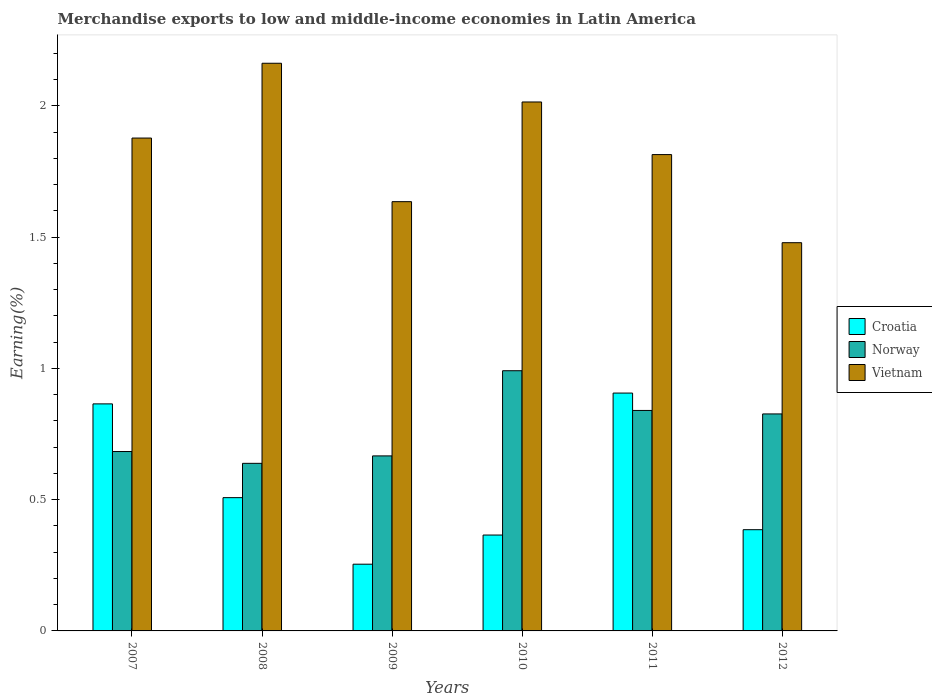How many groups of bars are there?
Your answer should be very brief. 6. Are the number of bars per tick equal to the number of legend labels?
Your answer should be compact. Yes. How many bars are there on the 1st tick from the left?
Your answer should be very brief. 3. How many bars are there on the 2nd tick from the right?
Your response must be concise. 3. What is the label of the 5th group of bars from the left?
Ensure brevity in your answer.  2011. What is the percentage of amount earned from merchandise exports in Croatia in 2010?
Your answer should be very brief. 0.37. Across all years, what is the maximum percentage of amount earned from merchandise exports in Croatia?
Your answer should be very brief. 0.91. Across all years, what is the minimum percentage of amount earned from merchandise exports in Vietnam?
Ensure brevity in your answer.  1.48. In which year was the percentage of amount earned from merchandise exports in Croatia minimum?
Ensure brevity in your answer.  2009. What is the total percentage of amount earned from merchandise exports in Croatia in the graph?
Ensure brevity in your answer.  3.28. What is the difference between the percentage of amount earned from merchandise exports in Croatia in 2008 and that in 2010?
Keep it short and to the point. 0.14. What is the difference between the percentage of amount earned from merchandise exports in Vietnam in 2011 and the percentage of amount earned from merchandise exports in Croatia in 2010?
Offer a terse response. 1.45. What is the average percentage of amount earned from merchandise exports in Croatia per year?
Ensure brevity in your answer.  0.55. In the year 2008, what is the difference between the percentage of amount earned from merchandise exports in Norway and percentage of amount earned from merchandise exports in Croatia?
Give a very brief answer. 0.13. What is the ratio of the percentage of amount earned from merchandise exports in Norway in 2007 to that in 2008?
Ensure brevity in your answer.  1.07. Is the percentage of amount earned from merchandise exports in Vietnam in 2008 less than that in 2010?
Ensure brevity in your answer.  No. What is the difference between the highest and the second highest percentage of amount earned from merchandise exports in Norway?
Your response must be concise. 0.15. What is the difference between the highest and the lowest percentage of amount earned from merchandise exports in Vietnam?
Give a very brief answer. 0.68. In how many years, is the percentage of amount earned from merchandise exports in Norway greater than the average percentage of amount earned from merchandise exports in Norway taken over all years?
Provide a short and direct response. 3. Is the sum of the percentage of amount earned from merchandise exports in Croatia in 2007 and 2010 greater than the maximum percentage of amount earned from merchandise exports in Vietnam across all years?
Keep it short and to the point. No. What does the 1st bar from the left in 2009 represents?
Provide a succinct answer. Croatia. Are all the bars in the graph horizontal?
Your answer should be compact. No. How many years are there in the graph?
Give a very brief answer. 6. What is the difference between two consecutive major ticks on the Y-axis?
Your response must be concise. 0.5. Are the values on the major ticks of Y-axis written in scientific E-notation?
Your answer should be compact. No. Does the graph contain any zero values?
Ensure brevity in your answer.  No. Where does the legend appear in the graph?
Your answer should be compact. Center right. What is the title of the graph?
Ensure brevity in your answer.  Merchandise exports to low and middle-income economies in Latin America. What is the label or title of the X-axis?
Your answer should be very brief. Years. What is the label or title of the Y-axis?
Your response must be concise. Earning(%). What is the Earning(%) of Croatia in 2007?
Your response must be concise. 0.86. What is the Earning(%) of Norway in 2007?
Provide a succinct answer. 0.68. What is the Earning(%) in Vietnam in 2007?
Your response must be concise. 1.88. What is the Earning(%) of Croatia in 2008?
Provide a short and direct response. 0.51. What is the Earning(%) of Norway in 2008?
Your response must be concise. 0.64. What is the Earning(%) of Vietnam in 2008?
Provide a short and direct response. 2.16. What is the Earning(%) in Croatia in 2009?
Your answer should be compact. 0.25. What is the Earning(%) in Norway in 2009?
Provide a succinct answer. 0.67. What is the Earning(%) of Vietnam in 2009?
Give a very brief answer. 1.63. What is the Earning(%) in Croatia in 2010?
Your response must be concise. 0.37. What is the Earning(%) in Norway in 2010?
Provide a short and direct response. 0.99. What is the Earning(%) in Vietnam in 2010?
Ensure brevity in your answer.  2.01. What is the Earning(%) in Croatia in 2011?
Give a very brief answer. 0.91. What is the Earning(%) in Norway in 2011?
Provide a succinct answer. 0.84. What is the Earning(%) in Vietnam in 2011?
Your answer should be very brief. 1.81. What is the Earning(%) in Croatia in 2012?
Give a very brief answer. 0.39. What is the Earning(%) in Norway in 2012?
Ensure brevity in your answer.  0.83. What is the Earning(%) in Vietnam in 2012?
Ensure brevity in your answer.  1.48. Across all years, what is the maximum Earning(%) of Croatia?
Provide a succinct answer. 0.91. Across all years, what is the maximum Earning(%) in Norway?
Provide a succinct answer. 0.99. Across all years, what is the maximum Earning(%) in Vietnam?
Provide a succinct answer. 2.16. Across all years, what is the minimum Earning(%) of Croatia?
Make the answer very short. 0.25. Across all years, what is the minimum Earning(%) of Norway?
Offer a terse response. 0.64. Across all years, what is the minimum Earning(%) of Vietnam?
Your answer should be compact. 1.48. What is the total Earning(%) of Croatia in the graph?
Offer a very short reply. 3.28. What is the total Earning(%) of Norway in the graph?
Keep it short and to the point. 4.65. What is the total Earning(%) in Vietnam in the graph?
Your answer should be very brief. 10.98. What is the difference between the Earning(%) of Croatia in 2007 and that in 2008?
Your response must be concise. 0.36. What is the difference between the Earning(%) of Norway in 2007 and that in 2008?
Provide a succinct answer. 0.04. What is the difference between the Earning(%) in Vietnam in 2007 and that in 2008?
Offer a very short reply. -0.28. What is the difference between the Earning(%) of Croatia in 2007 and that in 2009?
Ensure brevity in your answer.  0.61. What is the difference between the Earning(%) of Norway in 2007 and that in 2009?
Provide a succinct answer. 0.02. What is the difference between the Earning(%) in Vietnam in 2007 and that in 2009?
Your answer should be very brief. 0.24. What is the difference between the Earning(%) of Croatia in 2007 and that in 2010?
Keep it short and to the point. 0.5. What is the difference between the Earning(%) of Norway in 2007 and that in 2010?
Provide a succinct answer. -0.31. What is the difference between the Earning(%) of Vietnam in 2007 and that in 2010?
Your answer should be compact. -0.14. What is the difference between the Earning(%) in Croatia in 2007 and that in 2011?
Your answer should be very brief. -0.04. What is the difference between the Earning(%) of Norway in 2007 and that in 2011?
Make the answer very short. -0.16. What is the difference between the Earning(%) in Vietnam in 2007 and that in 2011?
Your response must be concise. 0.06. What is the difference between the Earning(%) of Croatia in 2007 and that in 2012?
Give a very brief answer. 0.48. What is the difference between the Earning(%) in Norway in 2007 and that in 2012?
Keep it short and to the point. -0.14. What is the difference between the Earning(%) of Vietnam in 2007 and that in 2012?
Give a very brief answer. 0.4. What is the difference between the Earning(%) of Croatia in 2008 and that in 2009?
Make the answer very short. 0.25. What is the difference between the Earning(%) of Norway in 2008 and that in 2009?
Your answer should be very brief. -0.03. What is the difference between the Earning(%) in Vietnam in 2008 and that in 2009?
Offer a terse response. 0.53. What is the difference between the Earning(%) of Croatia in 2008 and that in 2010?
Provide a short and direct response. 0.14. What is the difference between the Earning(%) of Norway in 2008 and that in 2010?
Keep it short and to the point. -0.35. What is the difference between the Earning(%) in Vietnam in 2008 and that in 2010?
Your response must be concise. 0.15. What is the difference between the Earning(%) of Croatia in 2008 and that in 2011?
Make the answer very short. -0.4. What is the difference between the Earning(%) in Norway in 2008 and that in 2011?
Your answer should be very brief. -0.2. What is the difference between the Earning(%) of Vietnam in 2008 and that in 2011?
Keep it short and to the point. 0.35. What is the difference between the Earning(%) in Croatia in 2008 and that in 2012?
Your answer should be compact. 0.12. What is the difference between the Earning(%) in Norway in 2008 and that in 2012?
Offer a very short reply. -0.19. What is the difference between the Earning(%) in Vietnam in 2008 and that in 2012?
Offer a terse response. 0.68. What is the difference between the Earning(%) in Croatia in 2009 and that in 2010?
Ensure brevity in your answer.  -0.11. What is the difference between the Earning(%) of Norway in 2009 and that in 2010?
Offer a very short reply. -0.32. What is the difference between the Earning(%) of Vietnam in 2009 and that in 2010?
Offer a terse response. -0.38. What is the difference between the Earning(%) of Croatia in 2009 and that in 2011?
Keep it short and to the point. -0.65. What is the difference between the Earning(%) in Norway in 2009 and that in 2011?
Provide a succinct answer. -0.17. What is the difference between the Earning(%) in Vietnam in 2009 and that in 2011?
Your answer should be very brief. -0.18. What is the difference between the Earning(%) of Croatia in 2009 and that in 2012?
Make the answer very short. -0.13. What is the difference between the Earning(%) in Norway in 2009 and that in 2012?
Your answer should be very brief. -0.16. What is the difference between the Earning(%) of Vietnam in 2009 and that in 2012?
Offer a very short reply. 0.16. What is the difference between the Earning(%) of Croatia in 2010 and that in 2011?
Your answer should be compact. -0.54. What is the difference between the Earning(%) of Norway in 2010 and that in 2011?
Your answer should be compact. 0.15. What is the difference between the Earning(%) of Vietnam in 2010 and that in 2011?
Keep it short and to the point. 0.2. What is the difference between the Earning(%) of Croatia in 2010 and that in 2012?
Keep it short and to the point. -0.02. What is the difference between the Earning(%) in Norway in 2010 and that in 2012?
Ensure brevity in your answer.  0.16. What is the difference between the Earning(%) in Vietnam in 2010 and that in 2012?
Offer a terse response. 0.54. What is the difference between the Earning(%) of Croatia in 2011 and that in 2012?
Your response must be concise. 0.52. What is the difference between the Earning(%) in Norway in 2011 and that in 2012?
Offer a very short reply. 0.01. What is the difference between the Earning(%) in Vietnam in 2011 and that in 2012?
Make the answer very short. 0.34. What is the difference between the Earning(%) in Croatia in 2007 and the Earning(%) in Norway in 2008?
Keep it short and to the point. 0.23. What is the difference between the Earning(%) of Croatia in 2007 and the Earning(%) of Vietnam in 2008?
Make the answer very short. -1.3. What is the difference between the Earning(%) of Norway in 2007 and the Earning(%) of Vietnam in 2008?
Your answer should be compact. -1.48. What is the difference between the Earning(%) in Croatia in 2007 and the Earning(%) in Norway in 2009?
Offer a very short reply. 0.2. What is the difference between the Earning(%) in Croatia in 2007 and the Earning(%) in Vietnam in 2009?
Offer a very short reply. -0.77. What is the difference between the Earning(%) in Norway in 2007 and the Earning(%) in Vietnam in 2009?
Your answer should be compact. -0.95. What is the difference between the Earning(%) of Croatia in 2007 and the Earning(%) of Norway in 2010?
Provide a succinct answer. -0.13. What is the difference between the Earning(%) of Croatia in 2007 and the Earning(%) of Vietnam in 2010?
Make the answer very short. -1.15. What is the difference between the Earning(%) of Norway in 2007 and the Earning(%) of Vietnam in 2010?
Offer a very short reply. -1.33. What is the difference between the Earning(%) of Croatia in 2007 and the Earning(%) of Norway in 2011?
Your response must be concise. 0.03. What is the difference between the Earning(%) of Croatia in 2007 and the Earning(%) of Vietnam in 2011?
Offer a terse response. -0.95. What is the difference between the Earning(%) in Norway in 2007 and the Earning(%) in Vietnam in 2011?
Your answer should be compact. -1.13. What is the difference between the Earning(%) of Croatia in 2007 and the Earning(%) of Norway in 2012?
Offer a terse response. 0.04. What is the difference between the Earning(%) of Croatia in 2007 and the Earning(%) of Vietnam in 2012?
Give a very brief answer. -0.61. What is the difference between the Earning(%) of Norway in 2007 and the Earning(%) of Vietnam in 2012?
Give a very brief answer. -0.8. What is the difference between the Earning(%) in Croatia in 2008 and the Earning(%) in Norway in 2009?
Offer a very short reply. -0.16. What is the difference between the Earning(%) in Croatia in 2008 and the Earning(%) in Vietnam in 2009?
Give a very brief answer. -1.13. What is the difference between the Earning(%) in Norway in 2008 and the Earning(%) in Vietnam in 2009?
Your answer should be compact. -1. What is the difference between the Earning(%) of Croatia in 2008 and the Earning(%) of Norway in 2010?
Provide a short and direct response. -0.48. What is the difference between the Earning(%) of Croatia in 2008 and the Earning(%) of Vietnam in 2010?
Offer a very short reply. -1.51. What is the difference between the Earning(%) of Norway in 2008 and the Earning(%) of Vietnam in 2010?
Provide a short and direct response. -1.38. What is the difference between the Earning(%) of Croatia in 2008 and the Earning(%) of Norway in 2011?
Provide a succinct answer. -0.33. What is the difference between the Earning(%) in Croatia in 2008 and the Earning(%) in Vietnam in 2011?
Ensure brevity in your answer.  -1.31. What is the difference between the Earning(%) in Norway in 2008 and the Earning(%) in Vietnam in 2011?
Provide a short and direct response. -1.18. What is the difference between the Earning(%) of Croatia in 2008 and the Earning(%) of Norway in 2012?
Give a very brief answer. -0.32. What is the difference between the Earning(%) of Croatia in 2008 and the Earning(%) of Vietnam in 2012?
Make the answer very short. -0.97. What is the difference between the Earning(%) of Norway in 2008 and the Earning(%) of Vietnam in 2012?
Keep it short and to the point. -0.84. What is the difference between the Earning(%) in Croatia in 2009 and the Earning(%) in Norway in 2010?
Your response must be concise. -0.74. What is the difference between the Earning(%) in Croatia in 2009 and the Earning(%) in Vietnam in 2010?
Give a very brief answer. -1.76. What is the difference between the Earning(%) of Norway in 2009 and the Earning(%) of Vietnam in 2010?
Your answer should be compact. -1.35. What is the difference between the Earning(%) in Croatia in 2009 and the Earning(%) in Norway in 2011?
Your answer should be very brief. -0.59. What is the difference between the Earning(%) in Croatia in 2009 and the Earning(%) in Vietnam in 2011?
Keep it short and to the point. -1.56. What is the difference between the Earning(%) of Norway in 2009 and the Earning(%) of Vietnam in 2011?
Your response must be concise. -1.15. What is the difference between the Earning(%) of Croatia in 2009 and the Earning(%) of Norway in 2012?
Offer a terse response. -0.57. What is the difference between the Earning(%) in Croatia in 2009 and the Earning(%) in Vietnam in 2012?
Offer a very short reply. -1.22. What is the difference between the Earning(%) in Norway in 2009 and the Earning(%) in Vietnam in 2012?
Keep it short and to the point. -0.81. What is the difference between the Earning(%) of Croatia in 2010 and the Earning(%) of Norway in 2011?
Keep it short and to the point. -0.47. What is the difference between the Earning(%) of Croatia in 2010 and the Earning(%) of Vietnam in 2011?
Your response must be concise. -1.45. What is the difference between the Earning(%) in Norway in 2010 and the Earning(%) in Vietnam in 2011?
Your response must be concise. -0.82. What is the difference between the Earning(%) in Croatia in 2010 and the Earning(%) in Norway in 2012?
Offer a terse response. -0.46. What is the difference between the Earning(%) in Croatia in 2010 and the Earning(%) in Vietnam in 2012?
Offer a very short reply. -1.11. What is the difference between the Earning(%) in Norway in 2010 and the Earning(%) in Vietnam in 2012?
Give a very brief answer. -0.49. What is the difference between the Earning(%) of Croatia in 2011 and the Earning(%) of Norway in 2012?
Keep it short and to the point. 0.08. What is the difference between the Earning(%) of Croatia in 2011 and the Earning(%) of Vietnam in 2012?
Give a very brief answer. -0.57. What is the difference between the Earning(%) in Norway in 2011 and the Earning(%) in Vietnam in 2012?
Offer a terse response. -0.64. What is the average Earning(%) of Croatia per year?
Provide a succinct answer. 0.55. What is the average Earning(%) of Norway per year?
Your answer should be compact. 0.77. What is the average Earning(%) of Vietnam per year?
Provide a succinct answer. 1.83. In the year 2007, what is the difference between the Earning(%) in Croatia and Earning(%) in Norway?
Offer a very short reply. 0.18. In the year 2007, what is the difference between the Earning(%) in Croatia and Earning(%) in Vietnam?
Ensure brevity in your answer.  -1.01. In the year 2007, what is the difference between the Earning(%) of Norway and Earning(%) of Vietnam?
Your response must be concise. -1.19. In the year 2008, what is the difference between the Earning(%) in Croatia and Earning(%) in Norway?
Provide a succinct answer. -0.13. In the year 2008, what is the difference between the Earning(%) of Croatia and Earning(%) of Vietnam?
Provide a short and direct response. -1.65. In the year 2008, what is the difference between the Earning(%) in Norway and Earning(%) in Vietnam?
Give a very brief answer. -1.52. In the year 2009, what is the difference between the Earning(%) in Croatia and Earning(%) in Norway?
Give a very brief answer. -0.41. In the year 2009, what is the difference between the Earning(%) of Croatia and Earning(%) of Vietnam?
Provide a succinct answer. -1.38. In the year 2009, what is the difference between the Earning(%) of Norway and Earning(%) of Vietnam?
Provide a succinct answer. -0.97. In the year 2010, what is the difference between the Earning(%) of Croatia and Earning(%) of Norway?
Make the answer very short. -0.63. In the year 2010, what is the difference between the Earning(%) of Croatia and Earning(%) of Vietnam?
Provide a short and direct response. -1.65. In the year 2010, what is the difference between the Earning(%) in Norway and Earning(%) in Vietnam?
Offer a very short reply. -1.02. In the year 2011, what is the difference between the Earning(%) in Croatia and Earning(%) in Norway?
Make the answer very short. 0.07. In the year 2011, what is the difference between the Earning(%) in Croatia and Earning(%) in Vietnam?
Your response must be concise. -0.91. In the year 2011, what is the difference between the Earning(%) of Norway and Earning(%) of Vietnam?
Your answer should be compact. -0.97. In the year 2012, what is the difference between the Earning(%) in Croatia and Earning(%) in Norway?
Keep it short and to the point. -0.44. In the year 2012, what is the difference between the Earning(%) of Croatia and Earning(%) of Vietnam?
Your answer should be compact. -1.09. In the year 2012, what is the difference between the Earning(%) in Norway and Earning(%) in Vietnam?
Ensure brevity in your answer.  -0.65. What is the ratio of the Earning(%) in Croatia in 2007 to that in 2008?
Your answer should be very brief. 1.7. What is the ratio of the Earning(%) of Norway in 2007 to that in 2008?
Provide a succinct answer. 1.07. What is the ratio of the Earning(%) of Vietnam in 2007 to that in 2008?
Your answer should be compact. 0.87. What is the ratio of the Earning(%) of Croatia in 2007 to that in 2009?
Offer a very short reply. 3.4. What is the ratio of the Earning(%) of Vietnam in 2007 to that in 2009?
Keep it short and to the point. 1.15. What is the ratio of the Earning(%) of Croatia in 2007 to that in 2010?
Your answer should be very brief. 2.37. What is the ratio of the Earning(%) in Norway in 2007 to that in 2010?
Make the answer very short. 0.69. What is the ratio of the Earning(%) in Vietnam in 2007 to that in 2010?
Keep it short and to the point. 0.93. What is the ratio of the Earning(%) in Croatia in 2007 to that in 2011?
Make the answer very short. 0.95. What is the ratio of the Earning(%) of Norway in 2007 to that in 2011?
Keep it short and to the point. 0.81. What is the ratio of the Earning(%) of Vietnam in 2007 to that in 2011?
Provide a short and direct response. 1.03. What is the ratio of the Earning(%) in Croatia in 2007 to that in 2012?
Provide a succinct answer. 2.24. What is the ratio of the Earning(%) of Norway in 2007 to that in 2012?
Your answer should be compact. 0.83. What is the ratio of the Earning(%) of Vietnam in 2007 to that in 2012?
Your response must be concise. 1.27. What is the ratio of the Earning(%) in Croatia in 2008 to that in 2009?
Your answer should be very brief. 2. What is the ratio of the Earning(%) of Norway in 2008 to that in 2009?
Make the answer very short. 0.96. What is the ratio of the Earning(%) in Vietnam in 2008 to that in 2009?
Offer a terse response. 1.32. What is the ratio of the Earning(%) in Croatia in 2008 to that in 2010?
Your answer should be very brief. 1.39. What is the ratio of the Earning(%) of Norway in 2008 to that in 2010?
Offer a terse response. 0.64. What is the ratio of the Earning(%) of Vietnam in 2008 to that in 2010?
Your answer should be very brief. 1.07. What is the ratio of the Earning(%) of Croatia in 2008 to that in 2011?
Make the answer very short. 0.56. What is the ratio of the Earning(%) of Norway in 2008 to that in 2011?
Your response must be concise. 0.76. What is the ratio of the Earning(%) in Vietnam in 2008 to that in 2011?
Make the answer very short. 1.19. What is the ratio of the Earning(%) of Croatia in 2008 to that in 2012?
Ensure brevity in your answer.  1.32. What is the ratio of the Earning(%) in Norway in 2008 to that in 2012?
Offer a terse response. 0.77. What is the ratio of the Earning(%) of Vietnam in 2008 to that in 2012?
Give a very brief answer. 1.46. What is the ratio of the Earning(%) of Croatia in 2009 to that in 2010?
Make the answer very short. 0.7. What is the ratio of the Earning(%) of Norway in 2009 to that in 2010?
Give a very brief answer. 0.67. What is the ratio of the Earning(%) of Vietnam in 2009 to that in 2010?
Ensure brevity in your answer.  0.81. What is the ratio of the Earning(%) of Croatia in 2009 to that in 2011?
Offer a very short reply. 0.28. What is the ratio of the Earning(%) in Norway in 2009 to that in 2011?
Your response must be concise. 0.79. What is the ratio of the Earning(%) of Vietnam in 2009 to that in 2011?
Ensure brevity in your answer.  0.9. What is the ratio of the Earning(%) in Croatia in 2009 to that in 2012?
Make the answer very short. 0.66. What is the ratio of the Earning(%) of Norway in 2009 to that in 2012?
Offer a terse response. 0.81. What is the ratio of the Earning(%) of Vietnam in 2009 to that in 2012?
Provide a succinct answer. 1.11. What is the ratio of the Earning(%) in Croatia in 2010 to that in 2011?
Provide a short and direct response. 0.4. What is the ratio of the Earning(%) of Norway in 2010 to that in 2011?
Provide a short and direct response. 1.18. What is the ratio of the Earning(%) in Vietnam in 2010 to that in 2011?
Offer a very short reply. 1.11. What is the ratio of the Earning(%) of Croatia in 2010 to that in 2012?
Provide a short and direct response. 0.95. What is the ratio of the Earning(%) of Norway in 2010 to that in 2012?
Provide a succinct answer. 1.2. What is the ratio of the Earning(%) of Vietnam in 2010 to that in 2012?
Provide a succinct answer. 1.36. What is the ratio of the Earning(%) of Croatia in 2011 to that in 2012?
Make the answer very short. 2.35. What is the ratio of the Earning(%) of Norway in 2011 to that in 2012?
Your answer should be very brief. 1.02. What is the ratio of the Earning(%) in Vietnam in 2011 to that in 2012?
Provide a succinct answer. 1.23. What is the difference between the highest and the second highest Earning(%) in Croatia?
Your response must be concise. 0.04. What is the difference between the highest and the second highest Earning(%) of Norway?
Provide a succinct answer. 0.15. What is the difference between the highest and the second highest Earning(%) of Vietnam?
Offer a terse response. 0.15. What is the difference between the highest and the lowest Earning(%) of Croatia?
Offer a very short reply. 0.65. What is the difference between the highest and the lowest Earning(%) in Norway?
Make the answer very short. 0.35. What is the difference between the highest and the lowest Earning(%) of Vietnam?
Offer a very short reply. 0.68. 